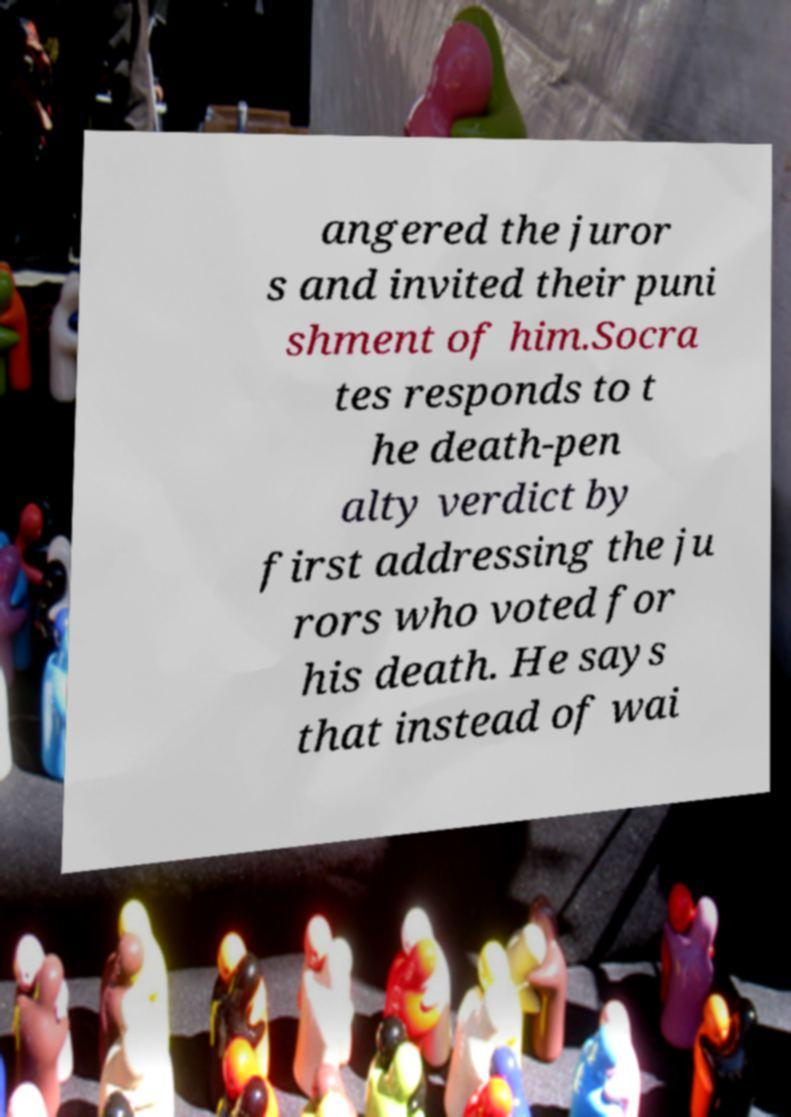Can you accurately transcribe the text from the provided image for me? angered the juror s and invited their puni shment of him.Socra tes responds to t he death-pen alty verdict by first addressing the ju rors who voted for his death. He says that instead of wai 